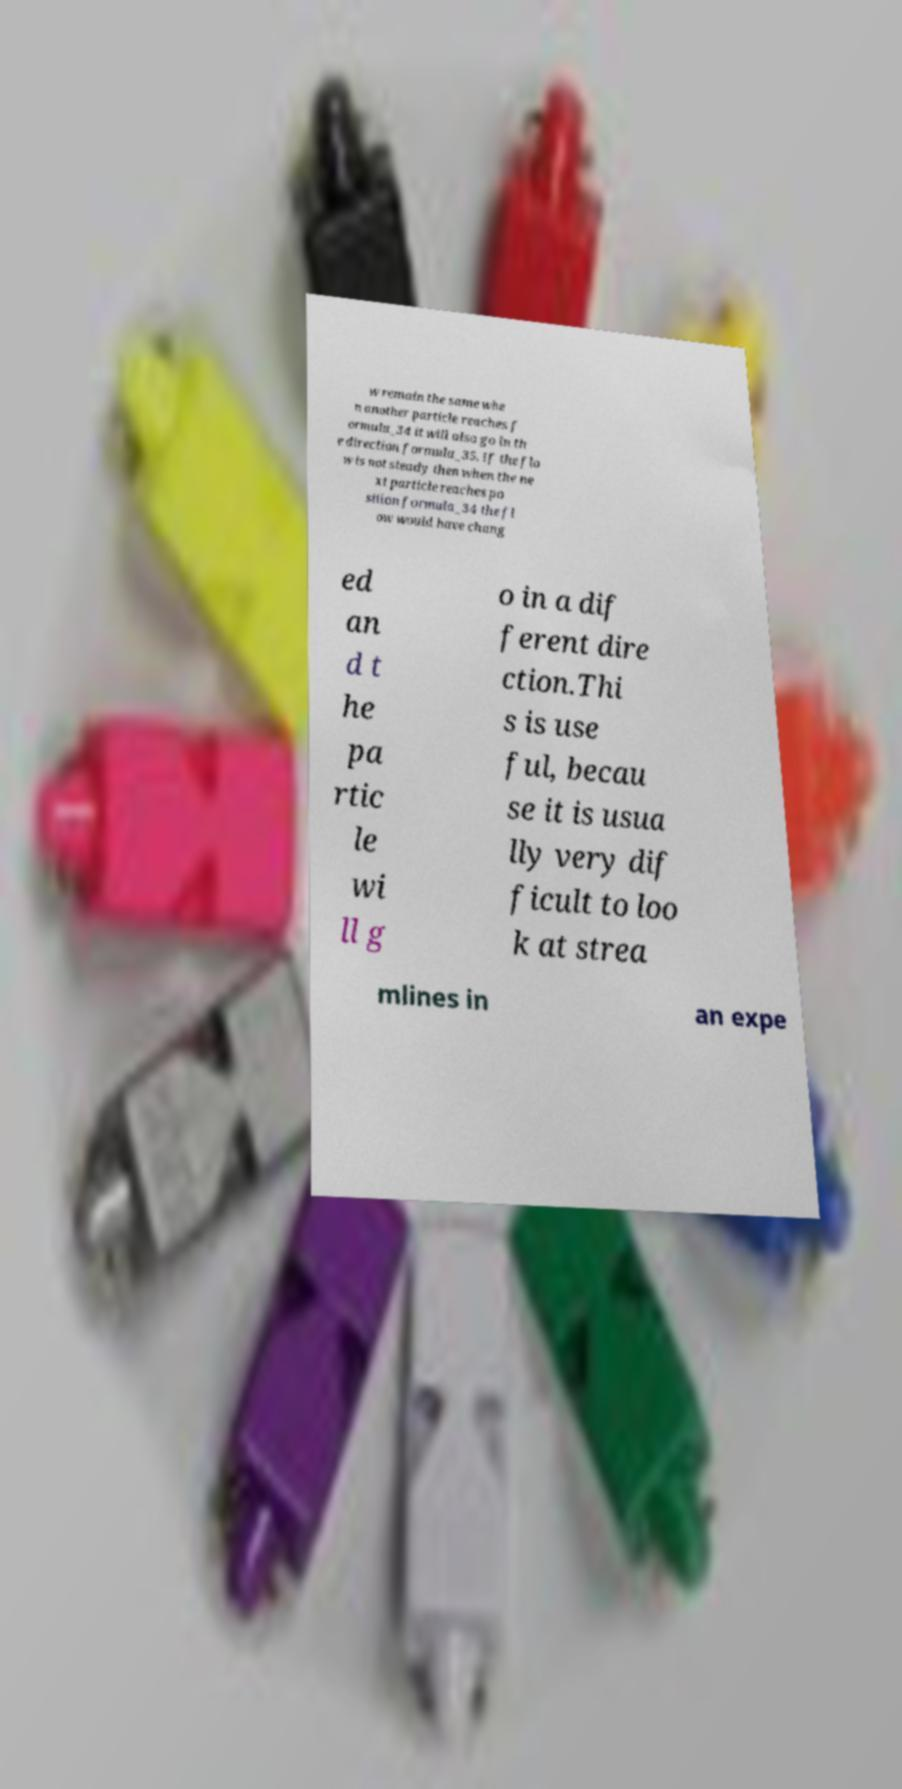There's text embedded in this image that I need extracted. Can you transcribe it verbatim? w remain the same whe n another particle reaches f ormula_34 it will also go in th e direction formula_35. If the flo w is not steady then when the ne xt particle reaches po sition formula_34 the fl ow would have chang ed an d t he pa rtic le wi ll g o in a dif ferent dire ction.Thi s is use ful, becau se it is usua lly very dif ficult to loo k at strea mlines in an expe 